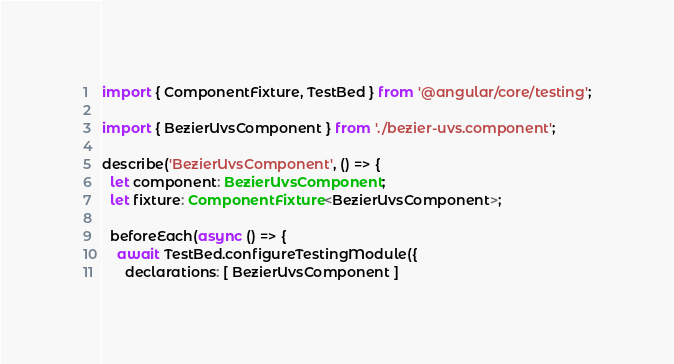<code> <loc_0><loc_0><loc_500><loc_500><_TypeScript_>import { ComponentFixture, TestBed } from '@angular/core/testing';

import { BezierUvsComponent } from './bezier-uvs.component';

describe('BezierUvsComponent', () => {
  let component: BezierUvsComponent;
  let fixture: ComponentFixture<BezierUvsComponent>;

  beforeEach(async () => {
    await TestBed.configureTestingModule({
      declarations: [ BezierUvsComponent ]</code> 